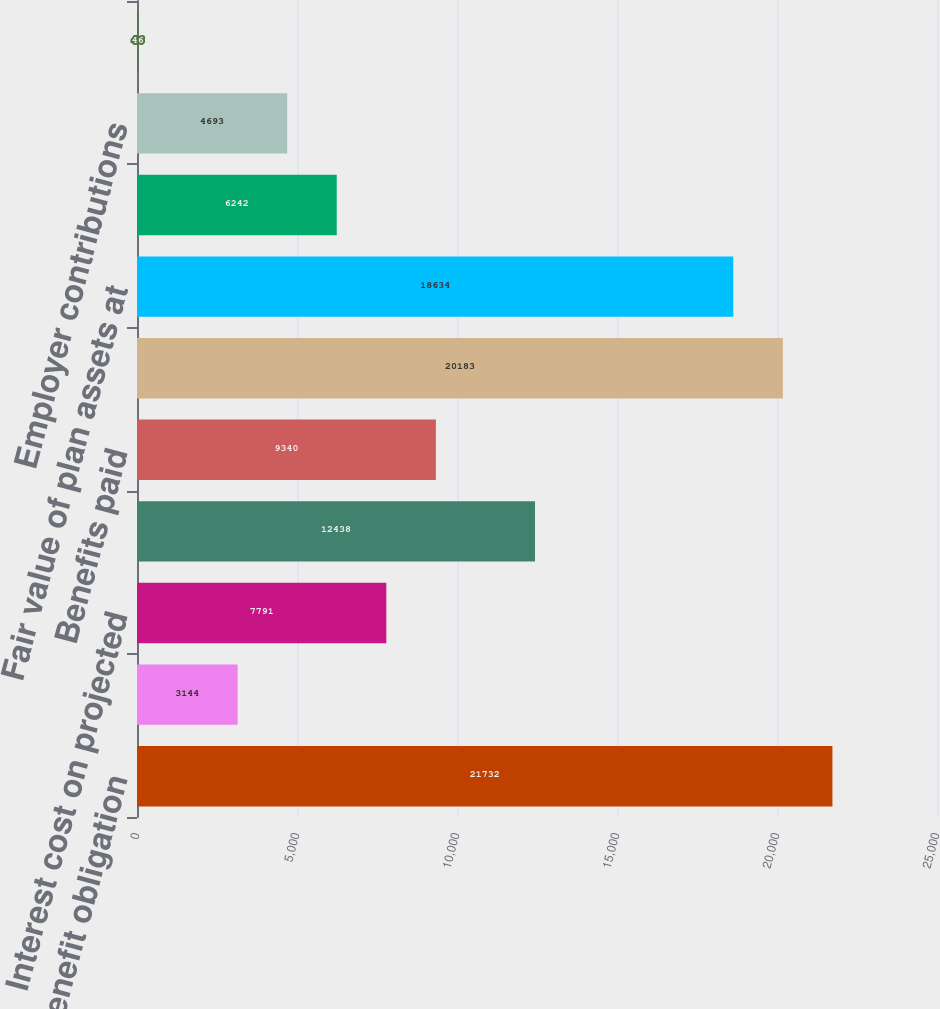<chart> <loc_0><loc_0><loc_500><loc_500><bar_chart><fcel>Projected benefit obligation<fcel>Service cost - excluding<fcel>Interest cost on projected<fcel>Net actuarial loss/(gain)<fcel>Benefits paid<fcel>PROJECTED BENEFIT OBLIGATION<fcel>Fair value of plan assets at<fcel>Actual return on plan assets<fcel>Employer contributions<fcel>Administrative expenses<nl><fcel>21732<fcel>3144<fcel>7791<fcel>12438<fcel>9340<fcel>20183<fcel>18634<fcel>6242<fcel>4693<fcel>46<nl></chart> 